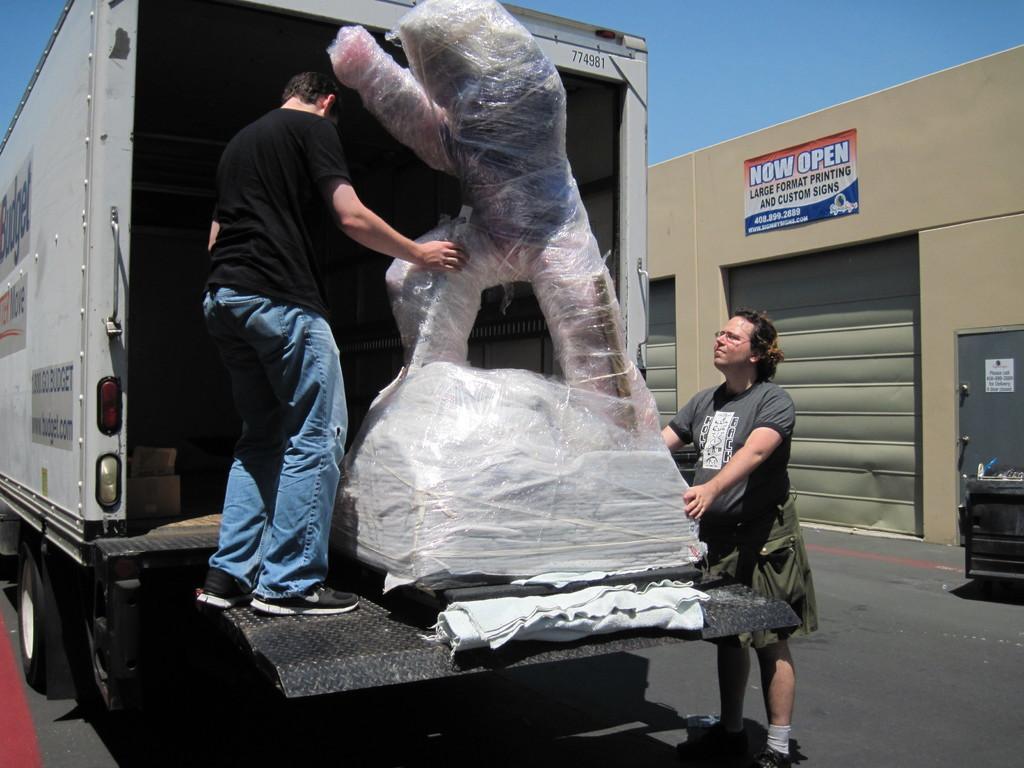How would you summarize this image in a sentence or two? This picture is clicked outside. In the center we can see a person wearing black color dress, holding an object and standing. On the right we can see another person wearing t-shirt, holding the object and standing and we can see a vehicle parked on the ground. In the background we can see the sky, text the poster attached to the wall and we can see the door and some other objects. 